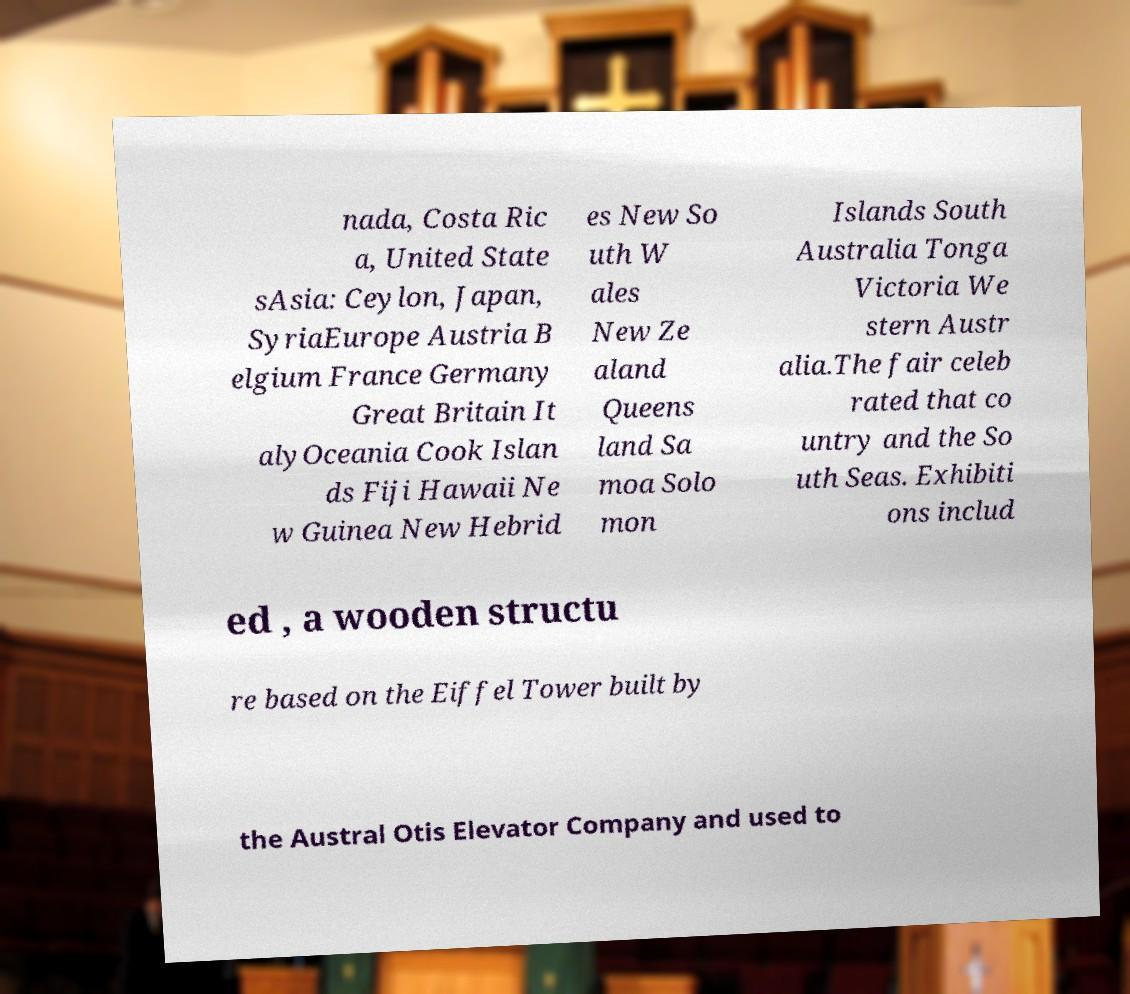Could you extract and type out the text from this image? nada, Costa Ric a, United State sAsia: Ceylon, Japan, SyriaEurope Austria B elgium France Germany Great Britain It alyOceania Cook Islan ds Fiji Hawaii Ne w Guinea New Hebrid es New So uth W ales New Ze aland Queens land Sa moa Solo mon Islands South Australia Tonga Victoria We stern Austr alia.The fair celeb rated that co untry and the So uth Seas. Exhibiti ons includ ed , a wooden structu re based on the Eiffel Tower built by the Austral Otis Elevator Company and used to 